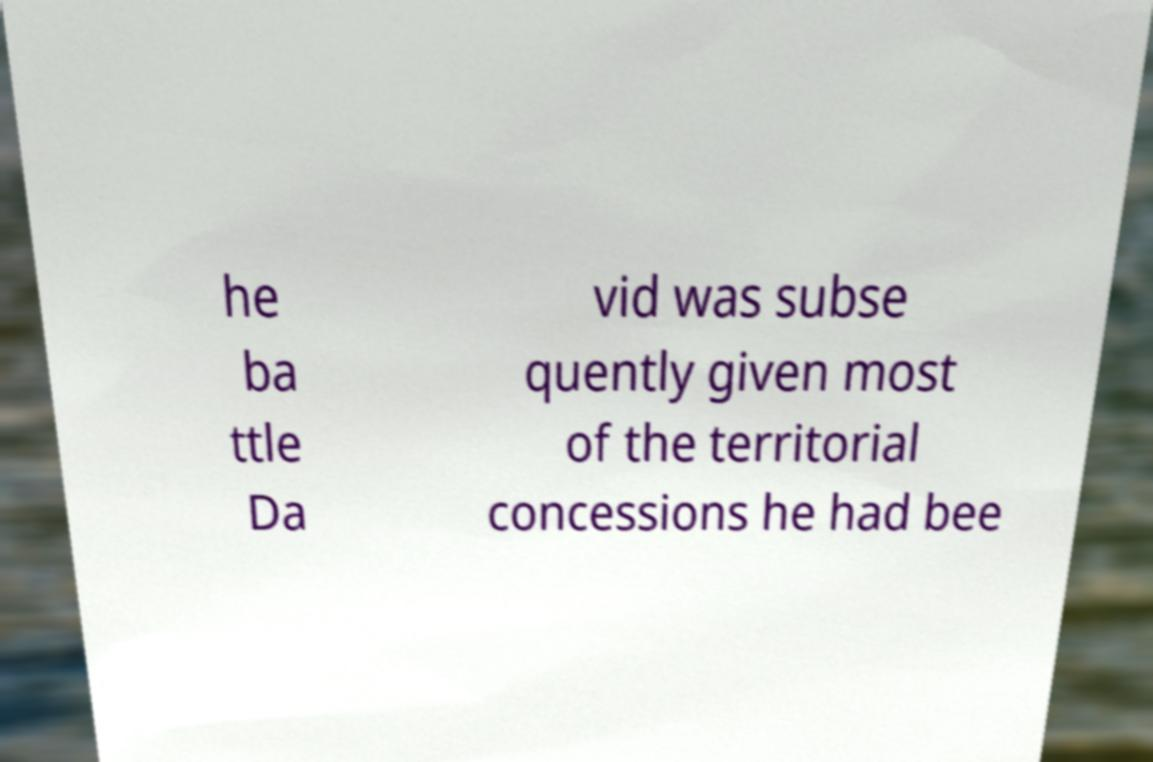Can you accurately transcribe the text from the provided image for me? he ba ttle Da vid was subse quently given most of the territorial concessions he had bee 